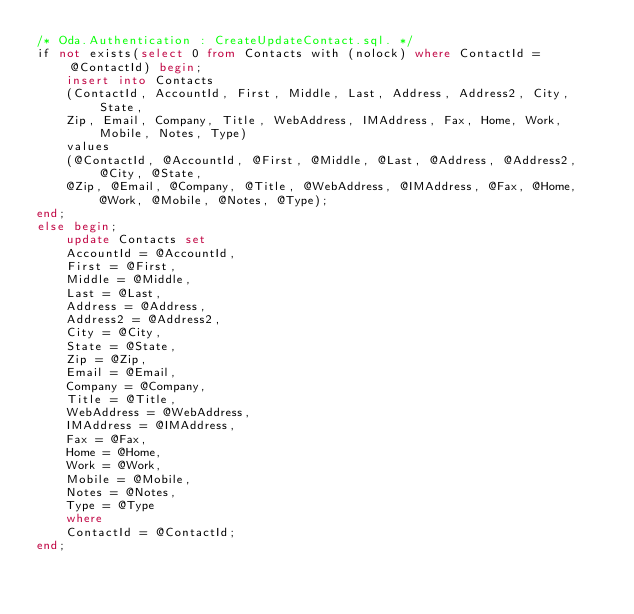Convert code to text. <code><loc_0><loc_0><loc_500><loc_500><_SQL_>/* Oda.Authentication : CreateUpdateContact.sql. */
if not exists(select 0 from Contacts with (nolock) where ContactId = @ContactId) begin;
	insert into Contacts 
	(ContactId, AccountId, First, Middle, Last, Address, Address2, City, State, 
	Zip, Email, Company, Title, WebAddress, IMAddress, Fax, Home, Work, Mobile, Notes, Type)
	values
	(@ContactId, @AccountId, @First, @Middle, @Last, @Address, @Address2, @City, @State, 
	@Zip, @Email, @Company, @Title, @WebAddress, @IMAddress, @Fax, @Home, @Work, @Mobile, @Notes, @Type);
end;
else begin;
	update Contacts set
	AccountId = @AccountId,
	First = @First,
	Middle = @Middle,
	Last = @Last,
	Address = @Address,
	Address2 = @Address2,
	City = @City,
	State = @State,
	Zip = @Zip,
	Email = @Email,
	Company = @Company,
	Title = @Title,
	WebAddress = @WebAddress,
	IMAddress = @IMAddress,
	Fax = @Fax,
	Home = @Home,
	Work = @Work,
	Mobile = @Mobile,
	Notes = @Notes,
	Type = @Type
	where
	ContactId = @ContactId;
end;</code> 